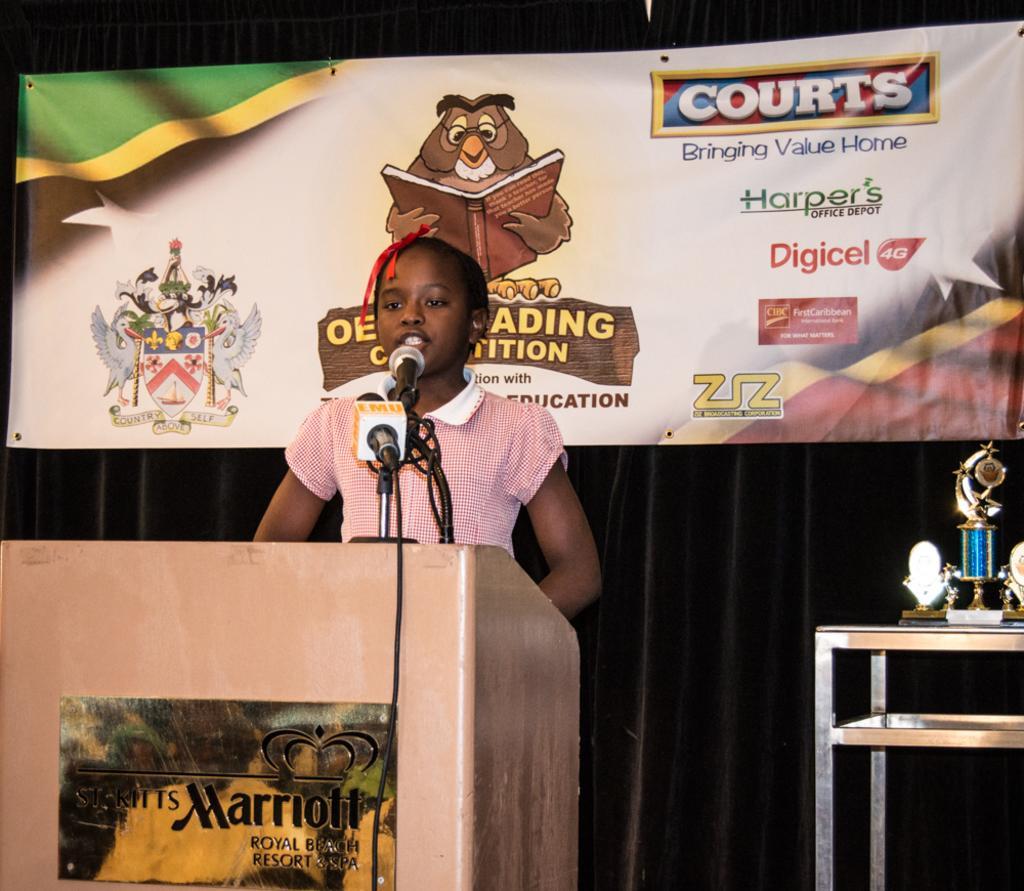In one or two sentences, can you explain what this image depicts? In this picture I can observe a girl standing in front of a podium. There are two mics on the podium. On the left side I can observe trophies placed on the table. In the background I can observe flex and black color curtain. 